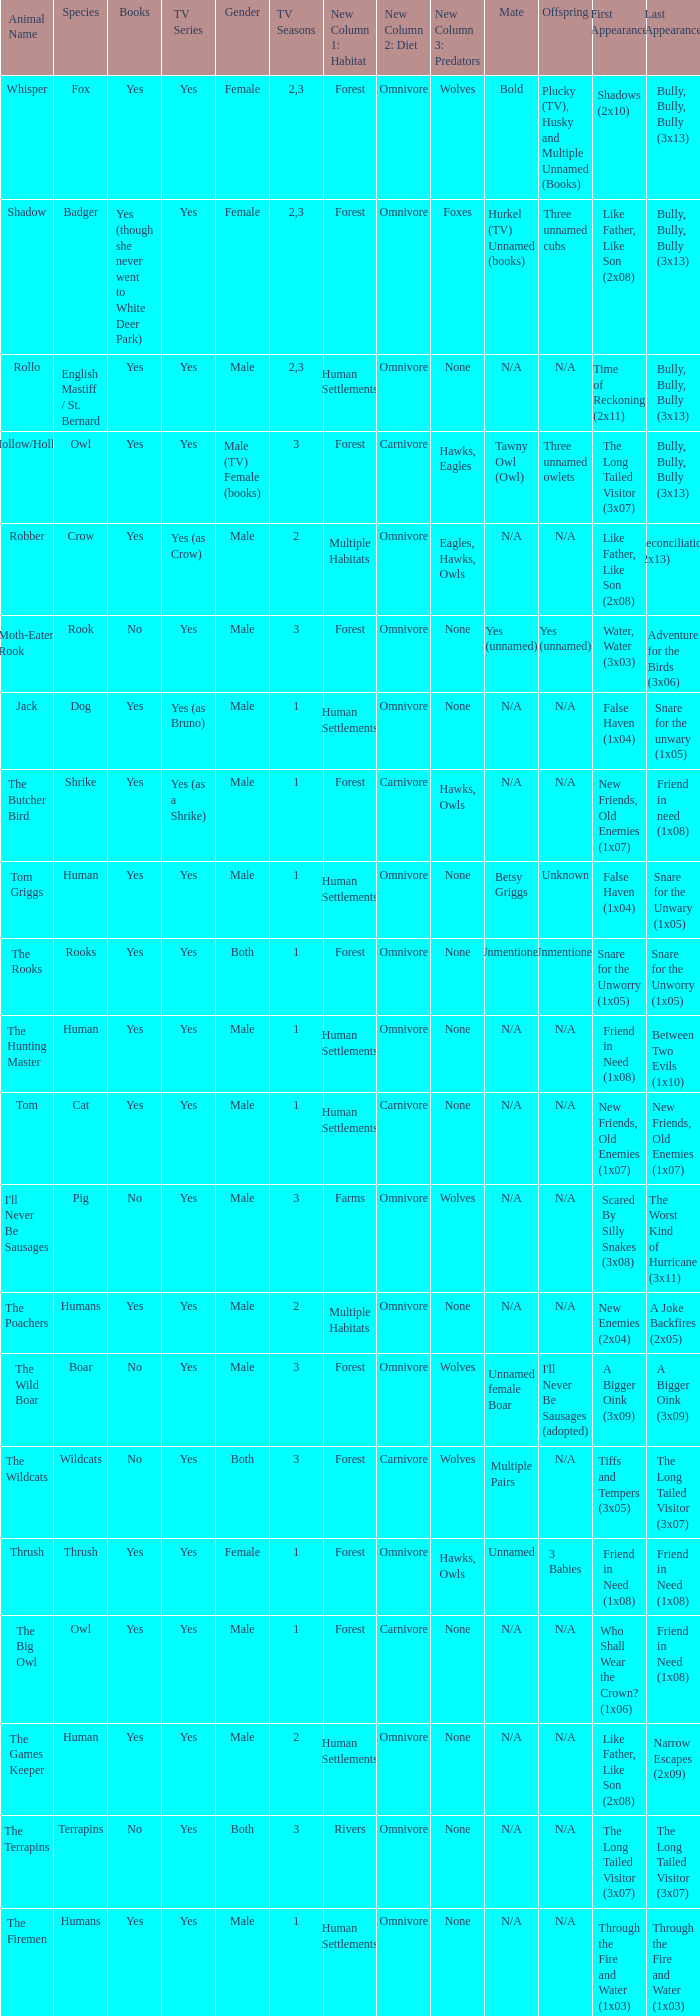What is the mate for Last Appearance of bully, bully, bully (3x13) for the animal named hollow/holly later than season 1? Tawny Owl (Owl). 